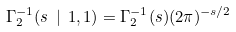<formula> <loc_0><loc_0><loc_500><loc_500>\Gamma ^ { - 1 } _ { 2 } ( s \ | \ 1 , 1 ) = \Gamma ^ { - 1 } _ { 2 } ( s ) ( 2 \pi ) ^ { - s / 2 }</formula> 